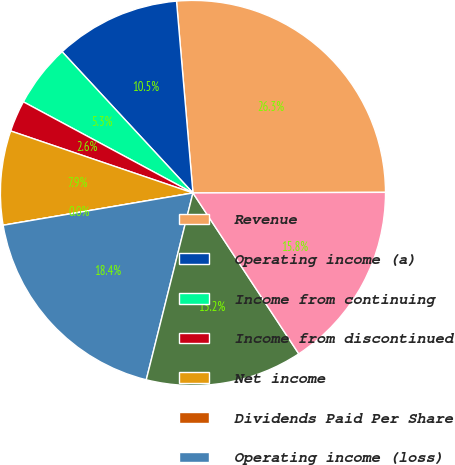Convert chart. <chart><loc_0><loc_0><loc_500><loc_500><pie_chart><fcel>Revenue<fcel>Operating income (a)<fcel>Income from continuing<fcel>Income from discontinued<fcel>Net income<fcel>Dividends Paid Per Share<fcel>Operating income (loss)<fcel>Income (loss) from continuing<fcel>Net income (loss)<nl><fcel>26.31%<fcel>10.53%<fcel>5.26%<fcel>2.63%<fcel>7.9%<fcel>0.0%<fcel>18.42%<fcel>13.16%<fcel>15.79%<nl></chart> 